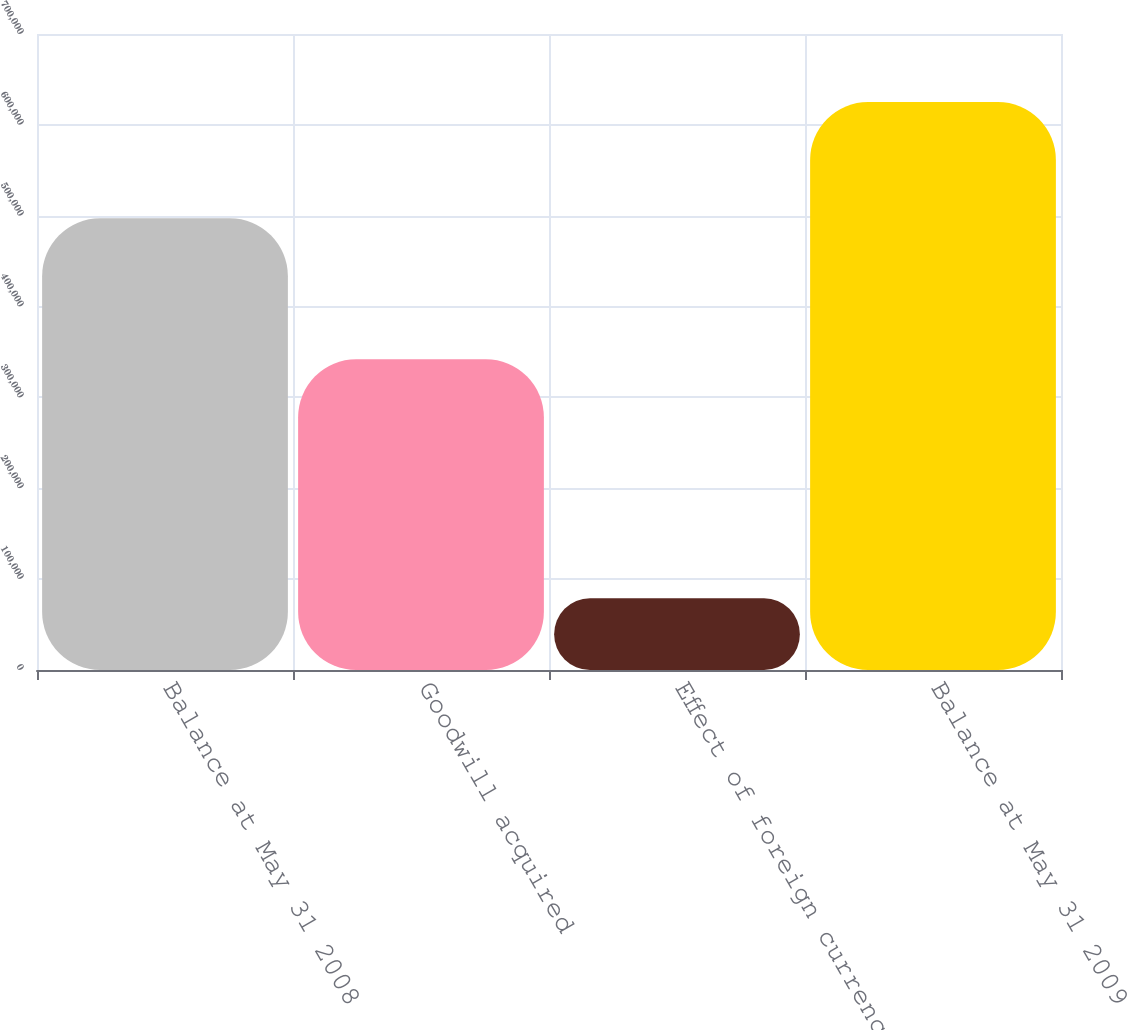Convert chart. <chart><loc_0><loc_0><loc_500><loc_500><bar_chart><fcel>Balance at May 31 2008<fcel>Goodwill acquired<fcel>Effect of foreign currency<fcel>Balance at May 31 2009<nl><fcel>497136<fcel>341928<fcel>78859<fcel>625120<nl></chart> 